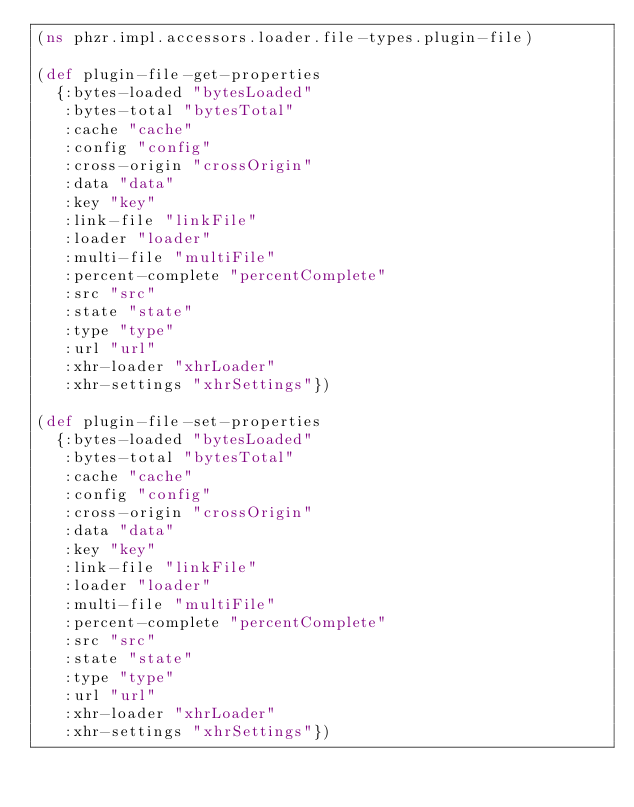Convert code to text. <code><loc_0><loc_0><loc_500><loc_500><_Clojure_>(ns phzr.impl.accessors.loader.file-types.plugin-file)

(def plugin-file-get-properties
  {:bytes-loaded "bytesLoaded"
   :bytes-total "bytesTotal"
   :cache "cache"
   :config "config"
   :cross-origin "crossOrigin"
   :data "data"
   :key "key"
   :link-file "linkFile"
   :loader "loader"
   :multi-file "multiFile"
   :percent-complete "percentComplete"
   :src "src"
   :state "state"
   :type "type"
   :url "url"
   :xhr-loader "xhrLoader"
   :xhr-settings "xhrSettings"})

(def plugin-file-set-properties
  {:bytes-loaded "bytesLoaded"
   :bytes-total "bytesTotal"
   :cache "cache"
   :config "config"
   :cross-origin "crossOrigin"
   :data "data"
   :key "key"
   :link-file "linkFile"
   :loader "loader"
   :multi-file "multiFile"
   :percent-complete "percentComplete"
   :src "src"
   :state "state"
   :type "type"
   :url "url"
   :xhr-loader "xhrLoader"
   :xhr-settings "xhrSettings"})</code> 